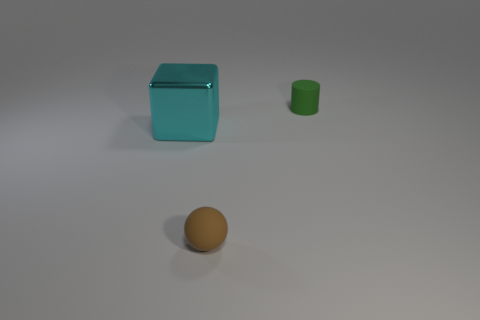Add 1 green rubber cylinders. How many objects exist? 4 Subtract all cylinders. How many objects are left? 2 Subtract 1 blocks. How many blocks are left? 0 Subtract all green blocks. How many red cylinders are left? 0 Subtract all green matte cylinders. Subtract all blue matte objects. How many objects are left? 2 Add 1 spheres. How many spheres are left? 2 Add 3 tiny cyan metallic blocks. How many tiny cyan metallic blocks exist? 3 Subtract 0 purple cubes. How many objects are left? 3 